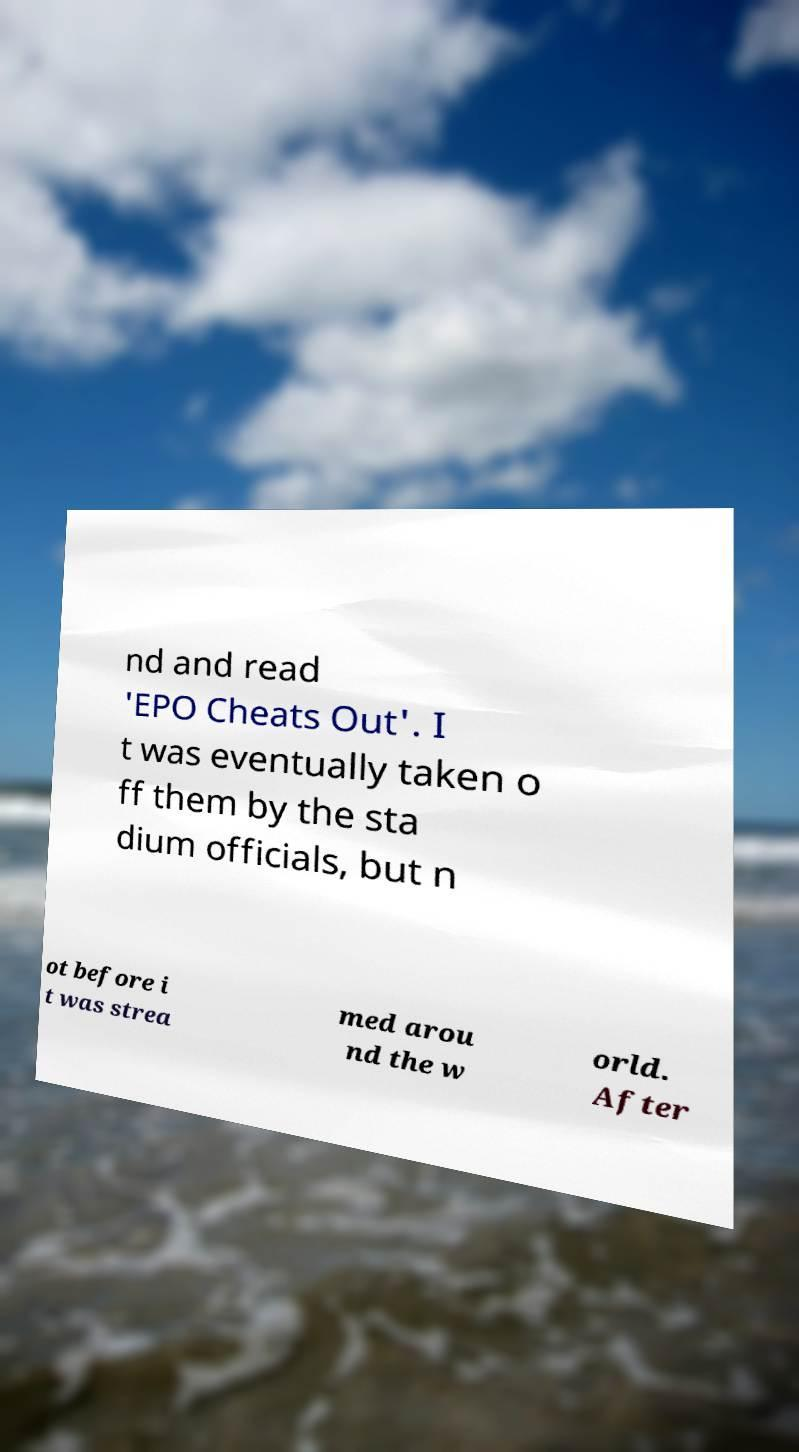There's text embedded in this image that I need extracted. Can you transcribe it verbatim? nd and read 'EPO Cheats Out'. I t was eventually taken o ff them by the sta dium officials, but n ot before i t was strea med arou nd the w orld. After 